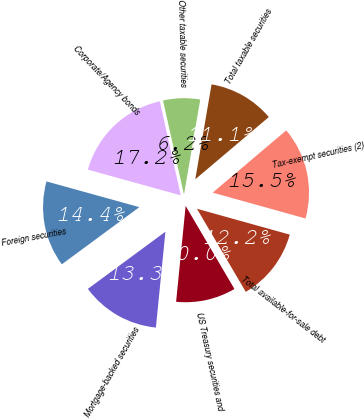<chart> <loc_0><loc_0><loc_500><loc_500><pie_chart><fcel>US Treasury securities and<fcel>Mortgage-backed securities<fcel>Foreign securities<fcel>Corporate/Agency bonds<fcel>Other taxable securities<fcel>Total taxable securities<fcel>Tax-exempt securities (2)<fcel>Total available-for-sale debt<nl><fcel>10.03%<fcel>13.31%<fcel>14.41%<fcel>17.21%<fcel>6.19%<fcel>11.12%<fcel>15.5%<fcel>12.22%<nl></chart> 